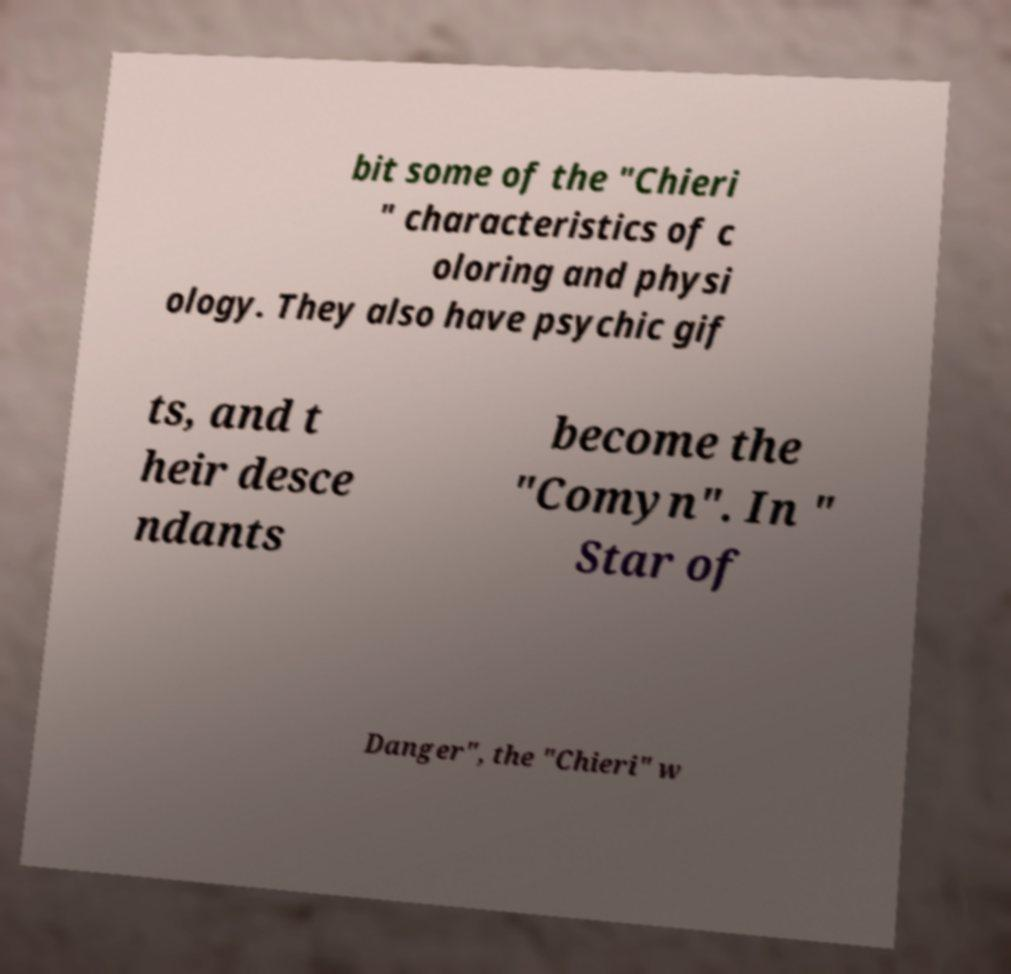Can you accurately transcribe the text from the provided image for me? bit some of the "Chieri " characteristics of c oloring and physi ology. They also have psychic gif ts, and t heir desce ndants become the "Comyn". In " Star of Danger", the "Chieri" w 